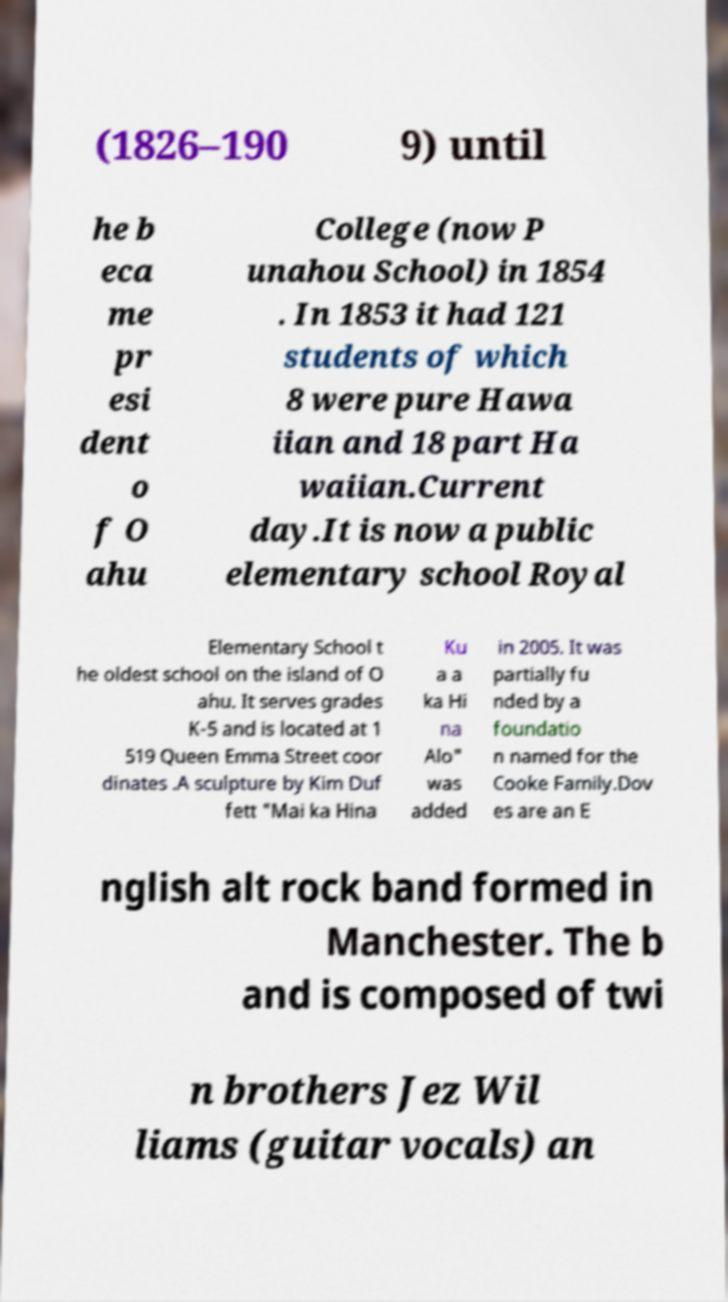Please identify and transcribe the text found in this image. (1826–190 9) until he b eca me pr esi dent o f O ahu College (now P unahou School) in 1854 . In 1853 it had 121 students of which 8 were pure Hawa iian and 18 part Ha waiian.Current day.It is now a public elementary school Royal Elementary School t he oldest school on the island of O ahu. It serves grades K-5 and is located at 1 519 Queen Emma Street coor dinates .A sculpture by Kim Duf fett "Mai ka Hina Ku a a ka Hi na Alo" was added in 2005. It was partially fu nded by a foundatio n named for the Cooke Family.Dov es are an E nglish alt rock band formed in Manchester. The b and is composed of twi n brothers Jez Wil liams (guitar vocals) an 